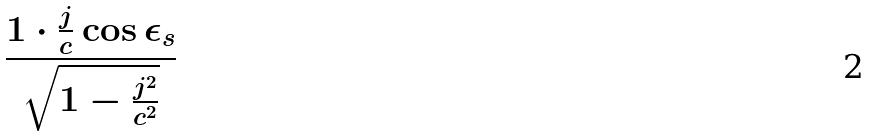<formula> <loc_0><loc_0><loc_500><loc_500>\frac { 1 \cdot \frac { j } { c } \cos \epsilon _ { s } } { \sqrt { 1 - \frac { j ^ { 2 } } { c ^ { 2 } } } }</formula> 